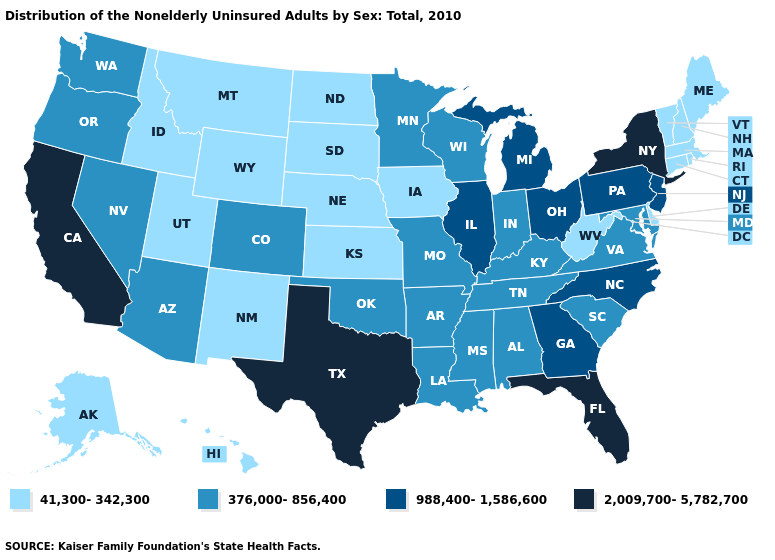Does New Hampshire have the same value as Louisiana?
Quick response, please. No. What is the lowest value in states that border Delaware?
Answer briefly. 376,000-856,400. What is the value of Missouri?
Quick response, please. 376,000-856,400. What is the value of Oregon?
Concise answer only. 376,000-856,400. Does Kentucky have a higher value than Maine?
Short answer required. Yes. Does Texas have the highest value in the South?
Write a very short answer. Yes. What is the highest value in states that border Louisiana?
Give a very brief answer. 2,009,700-5,782,700. What is the value of New York?
Give a very brief answer. 2,009,700-5,782,700. What is the value of Virginia?
Short answer required. 376,000-856,400. Does the map have missing data?
Write a very short answer. No. What is the lowest value in states that border New York?
Write a very short answer. 41,300-342,300. What is the lowest value in the MidWest?
Be succinct. 41,300-342,300. Does Illinois have the highest value in the USA?
Quick response, please. No. What is the lowest value in the South?
Short answer required. 41,300-342,300. Name the states that have a value in the range 2,009,700-5,782,700?
Short answer required. California, Florida, New York, Texas. 